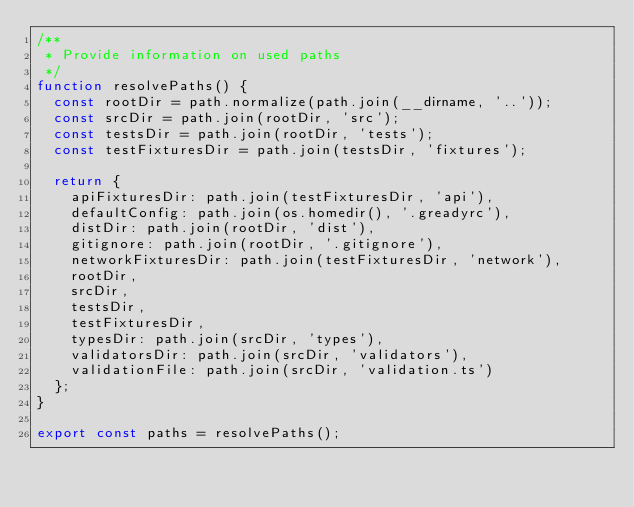Convert code to text. <code><loc_0><loc_0><loc_500><loc_500><_TypeScript_>/**
 * Provide information on used paths
 */
function resolvePaths() {
  const rootDir = path.normalize(path.join(__dirname, '..'));
  const srcDir = path.join(rootDir, 'src');
  const testsDir = path.join(rootDir, 'tests');
  const testFixturesDir = path.join(testsDir, 'fixtures');

  return {
    apiFixturesDir: path.join(testFixturesDir, 'api'),
    defaultConfig: path.join(os.homedir(), '.greadyrc'),
    distDir: path.join(rootDir, 'dist'),
    gitignore: path.join(rootDir, '.gitignore'),
    networkFixturesDir: path.join(testFixturesDir, 'network'),
    rootDir,
    srcDir,
    testsDir,
    testFixturesDir,
    typesDir: path.join(srcDir, 'types'),
    validatorsDir: path.join(srcDir, 'validators'),
    validationFile: path.join(srcDir, 'validation.ts')
  };
}

export const paths = resolvePaths();
</code> 